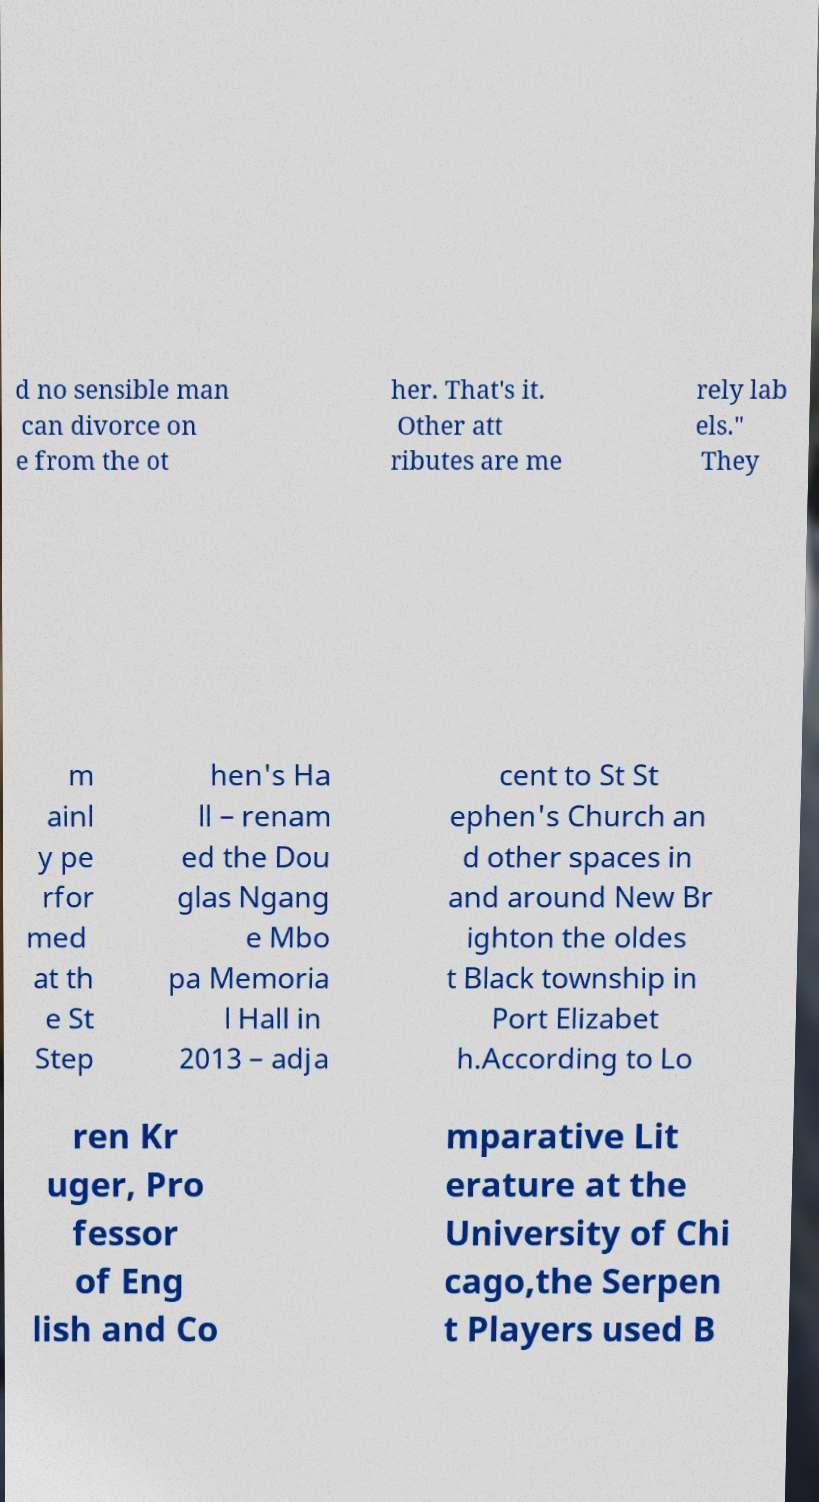Could you assist in decoding the text presented in this image and type it out clearly? d no sensible man can divorce on e from the ot her. That's it. Other att ributes are me rely lab els." They m ainl y pe rfor med at th e St Step hen's Ha ll – renam ed the Dou glas Ngang e Mbo pa Memoria l Hall in 2013 – adja cent to St St ephen's Church an d other spaces in and around New Br ighton the oldes t Black township in Port Elizabet h.According to Lo ren Kr uger, Pro fessor of Eng lish and Co mparative Lit erature at the University of Chi cago,the Serpen t Players used B 